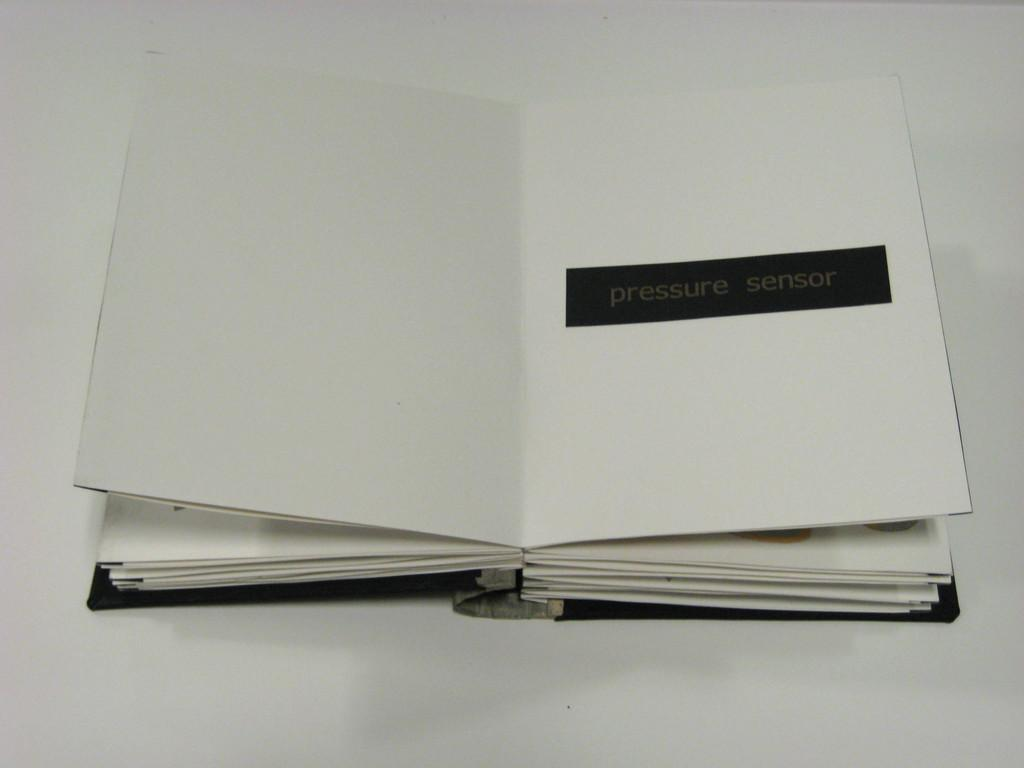Provide a one-sentence caption for the provided image. a book opened to nothing but a worded banner that says pressure sensor on the right hand side. 